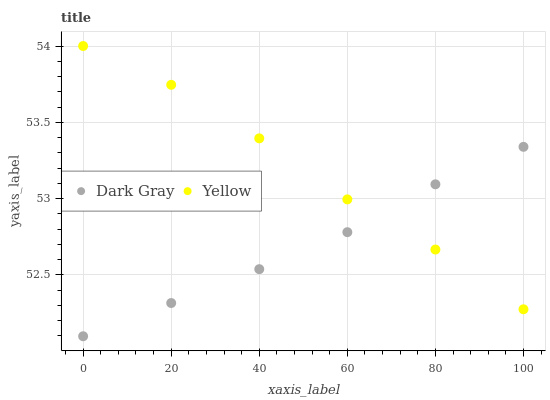Does Dark Gray have the minimum area under the curve?
Answer yes or no. Yes. Does Yellow have the maximum area under the curve?
Answer yes or no. Yes. Does Yellow have the minimum area under the curve?
Answer yes or no. No. Is Dark Gray the smoothest?
Answer yes or no. Yes. Is Yellow the roughest?
Answer yes or no. Yes. Is Yellow the smoothest?
Answer yes or no. No. Does Dark Gray have the lowest value?
Answer yes or no. Yes. Does Yellow have the lowest value?
Answer yes or no. No. Does Yellow have the highest value?
Answer yes or no. Yes. Does Yellow intersect Dark Gray?
Answer yes or no. Yes. Is Yellow less than Dark Gray?
Answer yes or no. No. Is Yellow greater than Dark Gray?
Answer yes or no. No. 